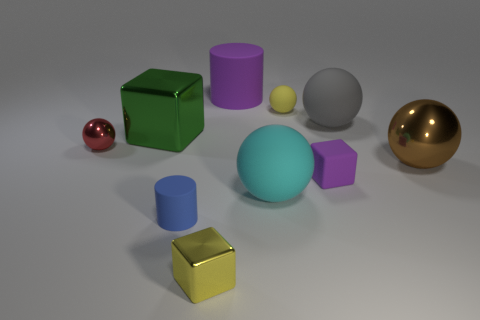Subtract all cyan balls. How many balls are left? 4 Subtract all small yellow balls. How many balls are left? 4 Subtract all blue spheres. Subtract all red blocks. How many spheres are left? 5 Subtract all cylinders. How many objects are left? 8 Subtract all small yellow cubes. Subtract all shiny balls. How many objects are left? 7 Add 7 green cubes. How many green cubes are left? 8 Add 8 cyan metal cubes. How many cyan metal cubes exist? 8 Subtract 1 yellow blocks. How many objects are left? 9 